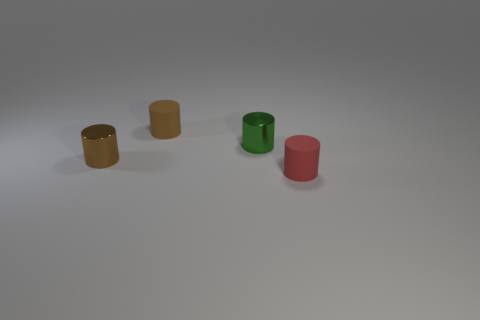Add 1 brown things. How many objects exist? 5 Subtract all brown shiny cylinders. Subtract all matte things. How many objects are left? 1 Add 4 small green objects. How many small green objects are left? 5 Add 4 tiny green objects. How many tiny green objects exist? 5 Subtract 0 yellow cylinders. How many objects are left? 4 